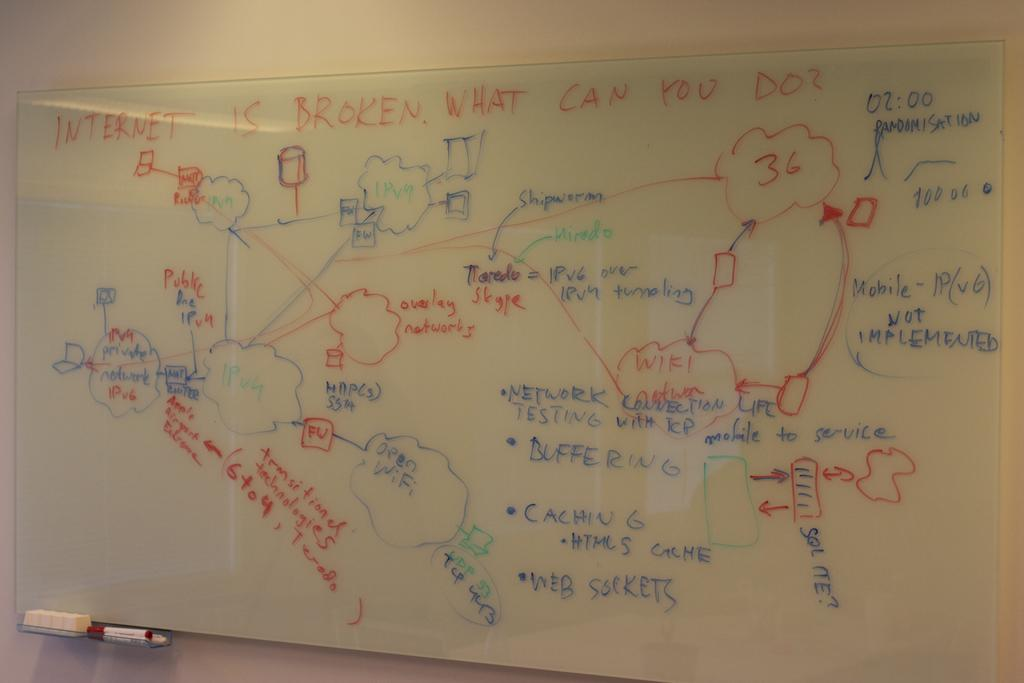<image>
Provide a brief description of the given image. A white board ask what can be done about the broken internet. 